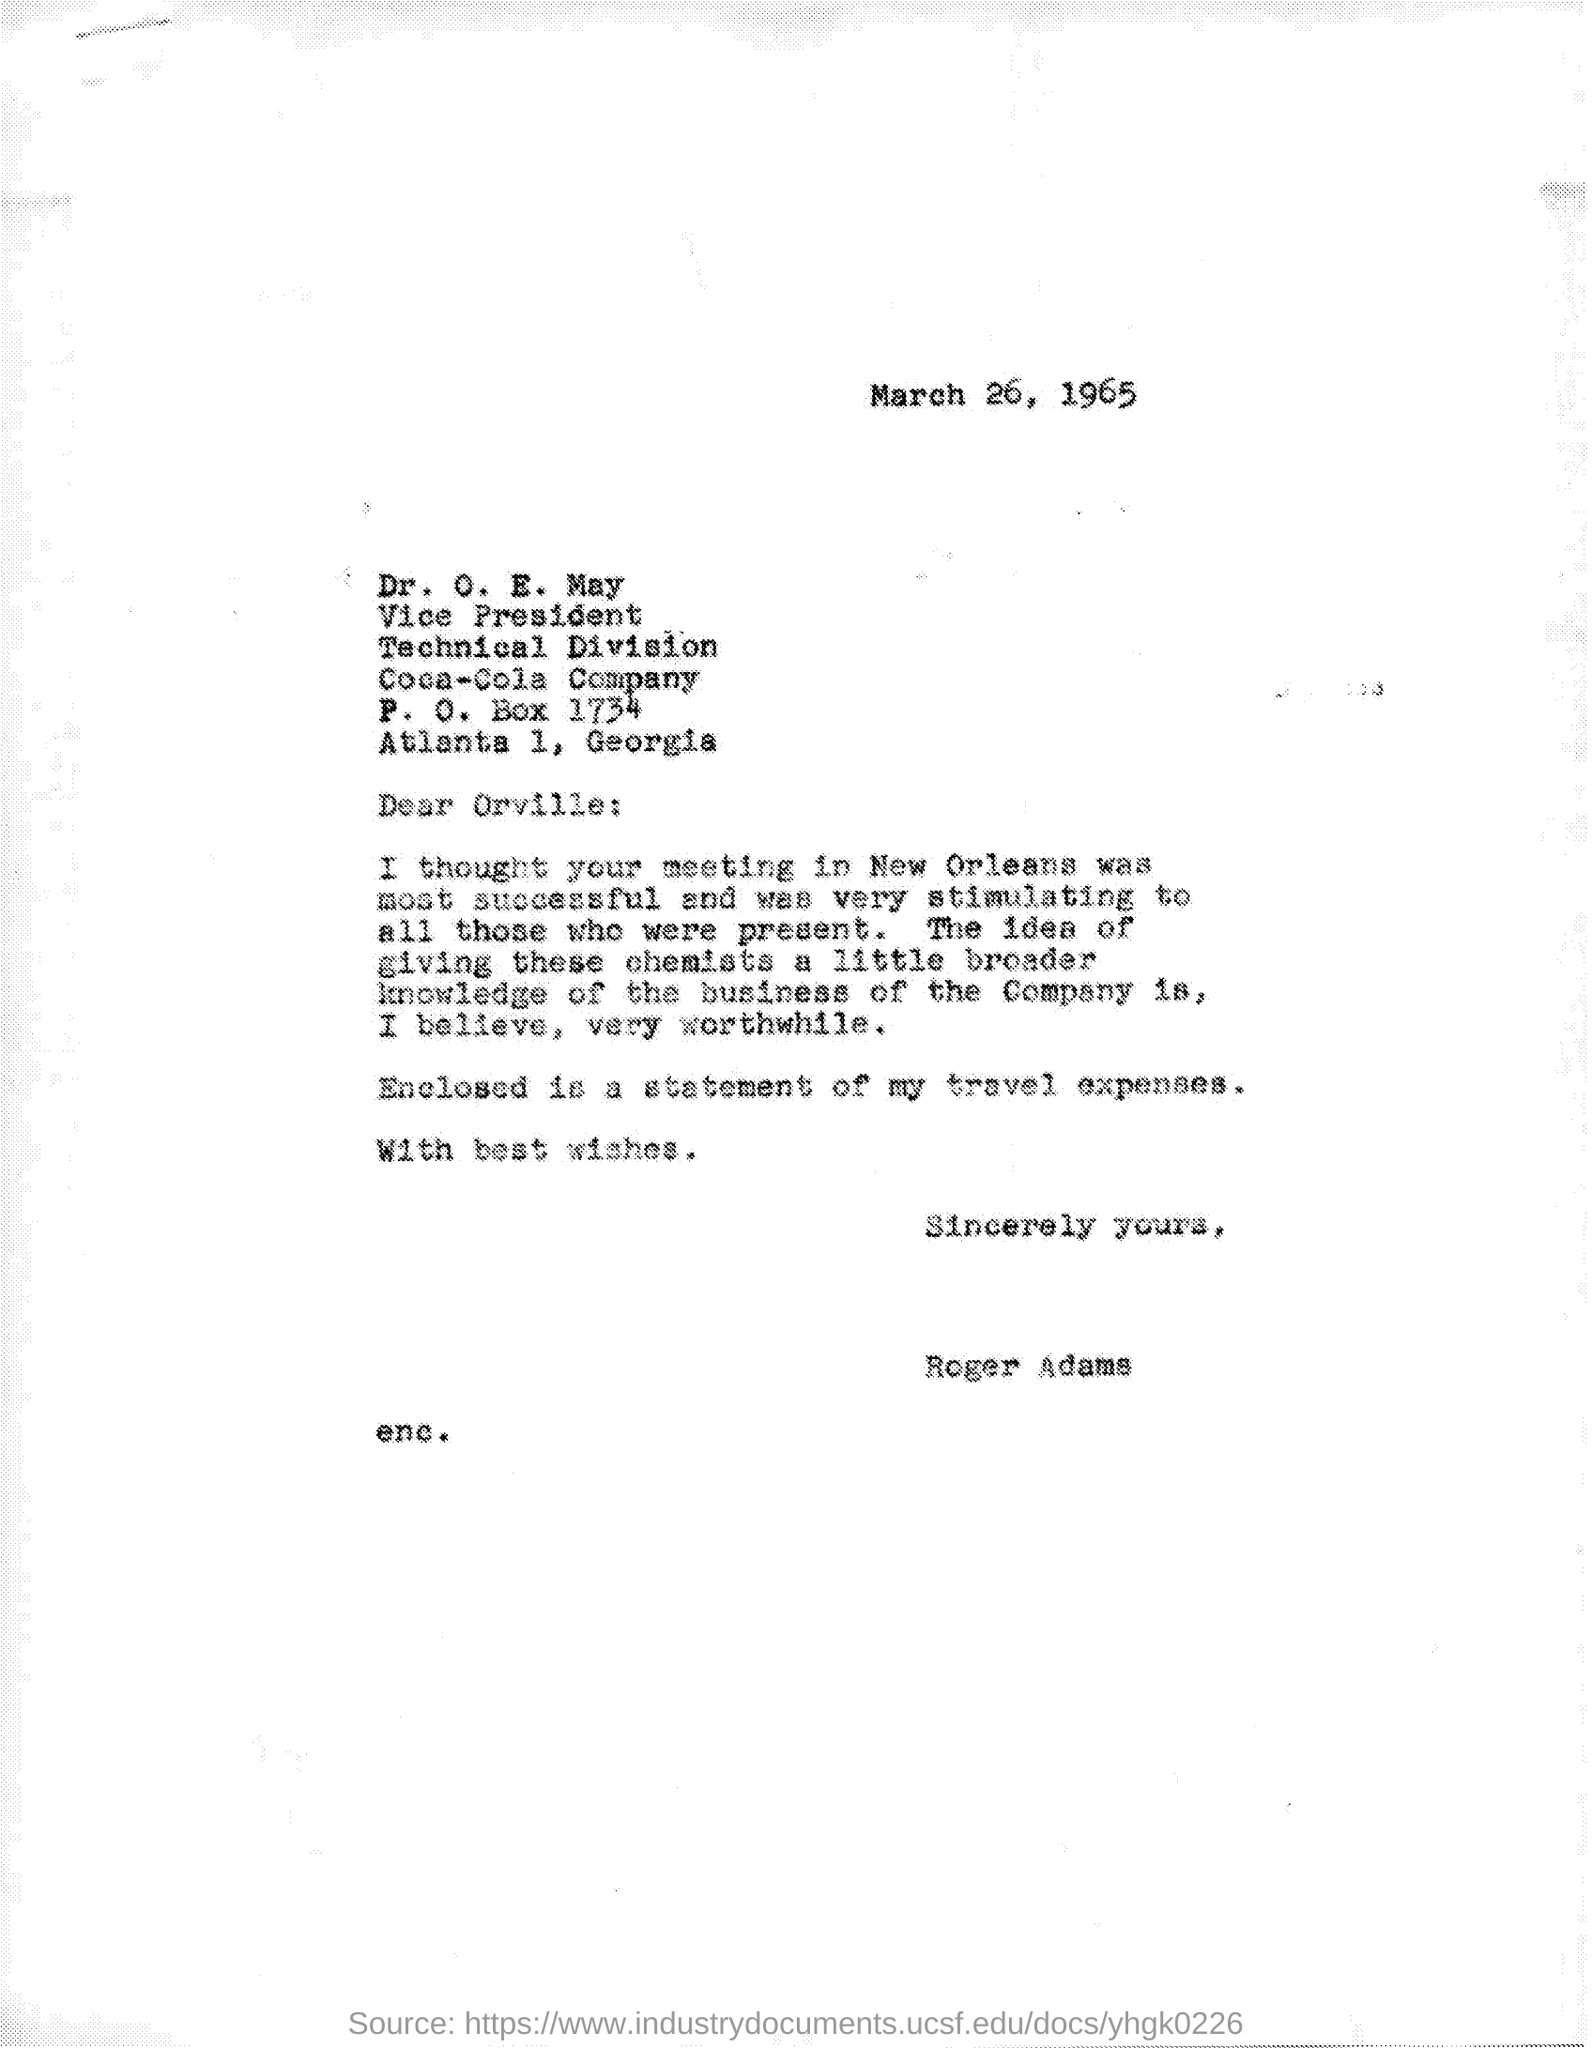Outline some significant characteristics in this image. Dr. O.E. May holds the designation of Vice President. The P.O.Box number mentioned in the given page is 1734. The letter was written to Dr. O. E. May. The division mentioned in the given letter is named Technical. 